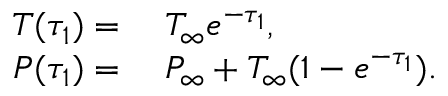Convert formula to latex. <formula><loc_0><loc_0><loc_500><loc_500>\begin{array} { r l } { T ( \tau _ { 1 } ) = } & \, T _ { \infty } e ^ { - \tau _ { 1 } } , } \\ { P ( \tau _ { 1 } ) = } & \, P _ { \infty } + T _ { \infty } ( 1 - e ^ { - \tau _ { 1 } } ) . } \end{array}</formula> 